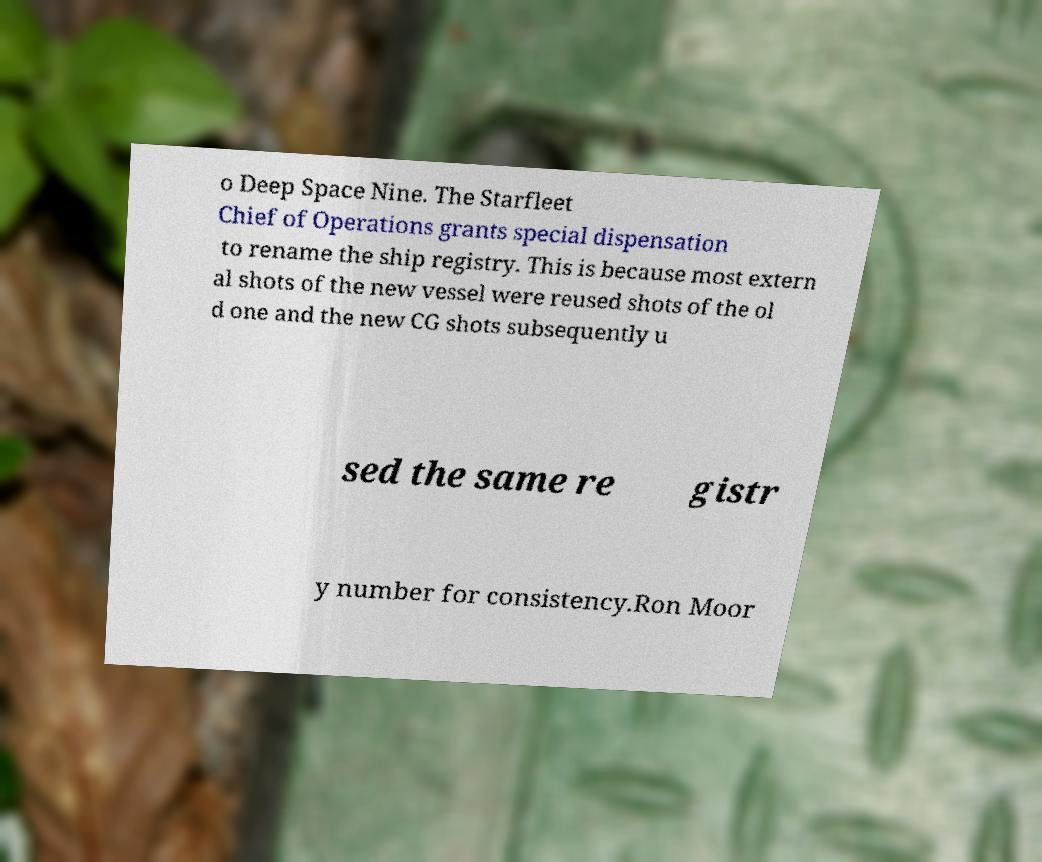I need the written content from this picture converted into text. Can you do that? o Deep Space Nine. The Starfleet Chief of Operations grants special dispensation to rename the ship registry. This is because most extern al shots of the new vessel were reused shots of the ol d one and the new CG shots subsequently u sed the same re gistr y number for consistency.Ron Moor 